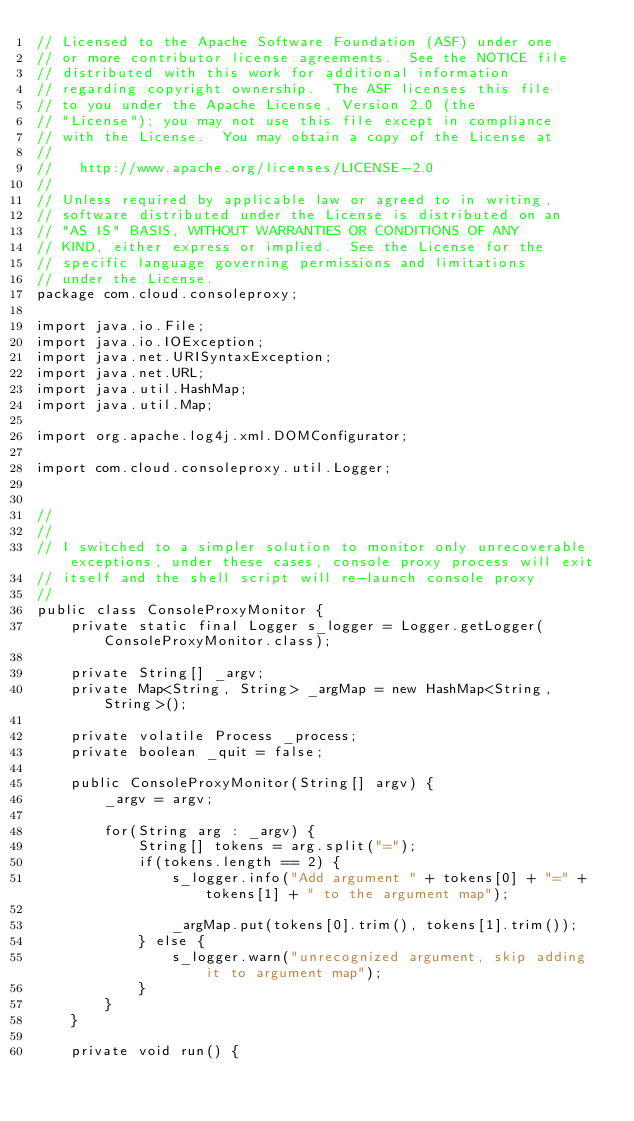Convert code to text. <code><loc_0><loc_0><loc_500><loc_500><_Java_>// Licensed to the Apache Software Foundation (ASF) under one
// or more contributor license agreements.  See the NOTICE file
// distributed with this work for additional information
// regarding copyright ownership.  The ASF licenses this file
// to you under the Apache License, Version 2.0 (the
// "License"); you may not use this file except in compliance
// with the License.  You may obtain a copy of the License at
//
//   http://www.apache.org/licenses/LICENSE-2.0
//
// Unless required by applicable law or agreed to in writing,
// software distributed under the License is distributed on an
// "AS IS" BASIS, WITHOUT WARRANTIES OR CONDITIONS OF ANY
// KIND, either express or implied.  See the License for the
// specific language governing permissions and limitations
// under the License.
package com.cloud.consoleproxy;

import java.io.File;
import java.io.IOException;
import java.net.URISyntaxException;
import java.net.URL;
import java.util.HashMap;
import java.util.Map;

import org.apache.log4j.xml.DOMConfigurator;

import com.cloud.consoleproxy.util.Logger;


//
//
// I switched to a simpler solution to monitor only unrecoverable exceptions, under these cases, console proxy process will exit
// itself and the shell script will re-launch console proxy
//
public class ConsoleProxyMonitor {
    private static final Logger s_logger = Logger.getLogger(ConsoleProxyMonitor.class);
    
    private String[] _argv;
    private Map<String, String> _argMap = new HashMap<String, String>();
    
    private volatile Process _process;
    private boolean _quit = false;
    
    public ConsoleProxyMonitor(String[] argv) {
        _argv = argv;
        
        for(String arg : _argv) {
            String[] tokens = arg.split("=");
            if(tokens.length == 2) {
                s_logger.info("Add argument " + tokens[0] + "=" + tokens[1] + " to the argument map");

                _argMap.put(tokens[0].trim(), tokens[1].trim());
            } else {
                s_logger.warn("unrecognized argument, skip adding it to argument map");
            }
        }
    }
    
    private void run() {</code> 